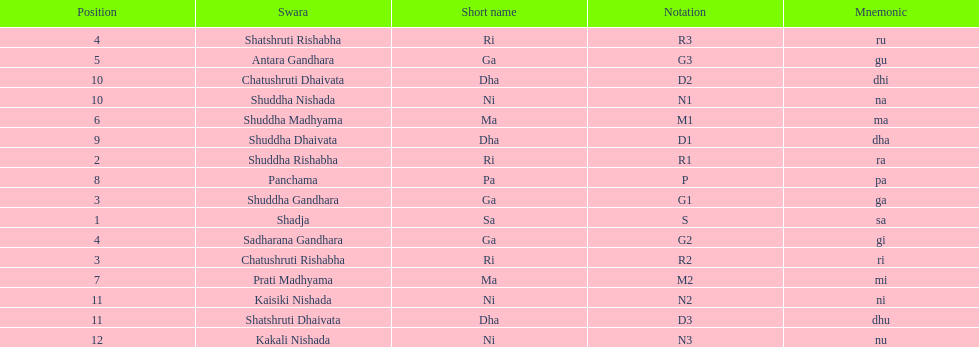List each pair of swaras that share the same position. Chatushruti Rishabha, Shuddha Gandhara, Shatshruti Rishabha, Sadharana Gandhara, Chatushruti Dhaivata, Shuddha Nishada, Shatshruti Dhaivata, Kaisiki Nishada. 